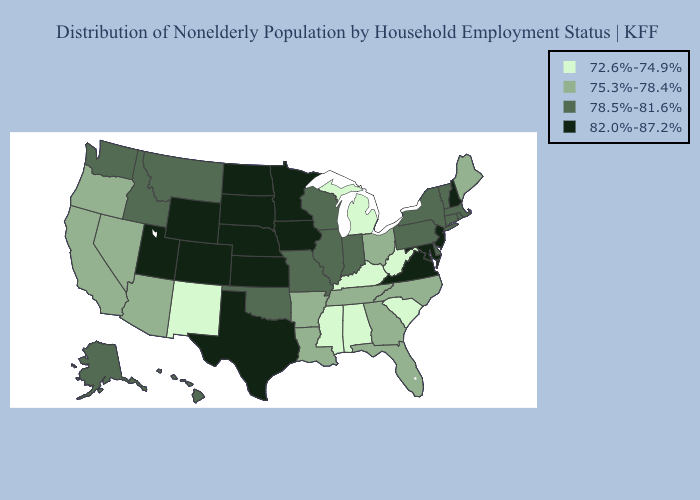Name the states that have a value in the range 78.5%-81.6%?
Answer briefly. Alaska, Connecticut, Delaware, Hawaii, Idaho, Illinois, Indiana, Massachusetts, Missouri, Montana, New York, Oklahoma, Pennsylvania, Rhode Island, Vermont, Washington, Wisconsin. What is the lowest value in the South?
Keep it brief. 72.6%-74.9%. Does Mississippi have the lowest value in the South?
Give a very brief answer. Yes. Name the states that have a value in the range 75.3%-78.4%?
Give a very brief answer. Arizona, Arkansas, California, Florida, Georgia, Louisiana, Maine, Nevada, North Carolina, Ohio, Oregon, Tennessee. What is the value of California?
Keep it brief. 75.3%-78.4%. Which states hav the highest value in the Northeast?
Short answer required. New Hampshire, New Jersey. What is the highest value in states that border Michigan?
Be succinct. 78.5%-81.6%. Is the legend a continuous bar?
Answer briefly. No. How many symbols are there in the legend?
Keep it brief. 4. Among the states that border Mississippi , which have the lowest value?
Concise answer only. Alabama. What is the highest value in the West ?
Answer briefly. 82.0%-87.2%. What is the highest value in states that border Mississippi?
Be succinct. 75.3%-78.4%. What is the lowest value in the West?
Give a very brief answer. 72.6%-74.9%. Does Mississippi have the lowest value in the USA?
Short answer required. Yes. What is the value of Florida?
Quick response, please. 75.3%-78.4%. 